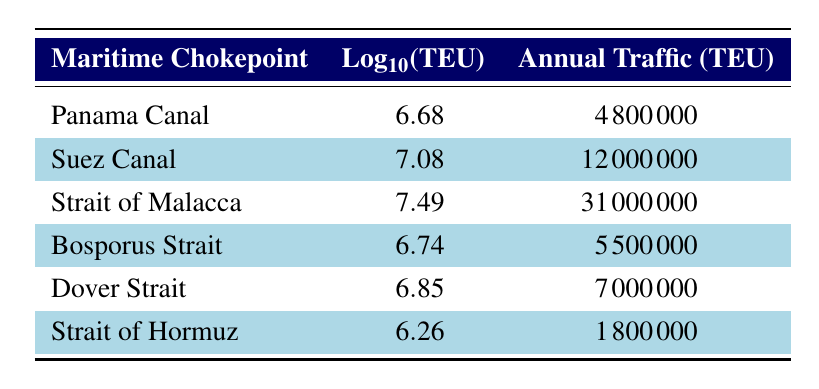What is the annual traffic volume for the Suez Canal? The table shows that the annual traffic volume for the Suez Canal is listed directly in the corresponding row, which states it is 12000000 TEU.
Answer: 12000000 TEU Which chokepoint has the lowest annual traffic volume? Looking through the annual traffic volume values in the table, the Strait of Hormuz has the lowest value at 1800000 TEU.
Answer: Strait of Hormuz What is the logarithmic value for the Bosporus Strait? The table directly provides the logarithmic value for the Bosporus Strait, which is listed as 6.74.
Answer: 6.74 Is the annual traffic volume for the Strait of Malacca greater than that for the Panama Canal? Comparing the two annual traffic volumes, the Strait of Malacca has a volume of 31000000 TEU while the Panama Canal has 4800000 TEU. Since 31000000 is greater than 4800000, the statement is true.
Answer: Yes What is the average annual traffic volume of all listed chokepoints? To find the average, we sum all the annual traffic volumes (4800000 + 12000000 + 31000000 + 5500000 + 7000000 + 1800000 = 62400000 TEU) and divide by the total number of chokepoints (6), resulting in an average of 10400000 TEU.
Answer: 10400000 TEU How much more annual traffic volume does the Strait of Malacca have compared to the Bosporus Strait? The annual traffic volume for the Strait of Malacca is 31000000 TEU and for the Bosporus Strait it is 5500000 TEU. Subtracting the two values (31000000 - 5500000) gives us a difference of 25500000 TEU.
Answer: 25500000 TEU Which chokepoint has a logarithmic value greater than 7? From the table, we can see that both the Suez Canal (7.08) and the Strait of Malacca (7.49) have logarithmic values greater than 7, while the other chokepoints do not.
Answer: Suez Canal and Strait of Malacca What is the difference in logarithmic value between the Dover Strait and the Strait of Hormuz? The logarithmic value for the Dover Strait is 6.85 and for the Strait of Hormuz it is 6.26. Subtracting these gives a difference of 6.85 - 6.26 = 0.59.
Answer: 0.59 Is the Panama Canal traffic volume equal to that of the Bosporus Strait? The annual traffic volume for the Panama Canal is 4800000 TEU, while for the Bosporus Strait it is 5500000 TEU. Since these two values are not equal, the statement is false.
Answer: No 